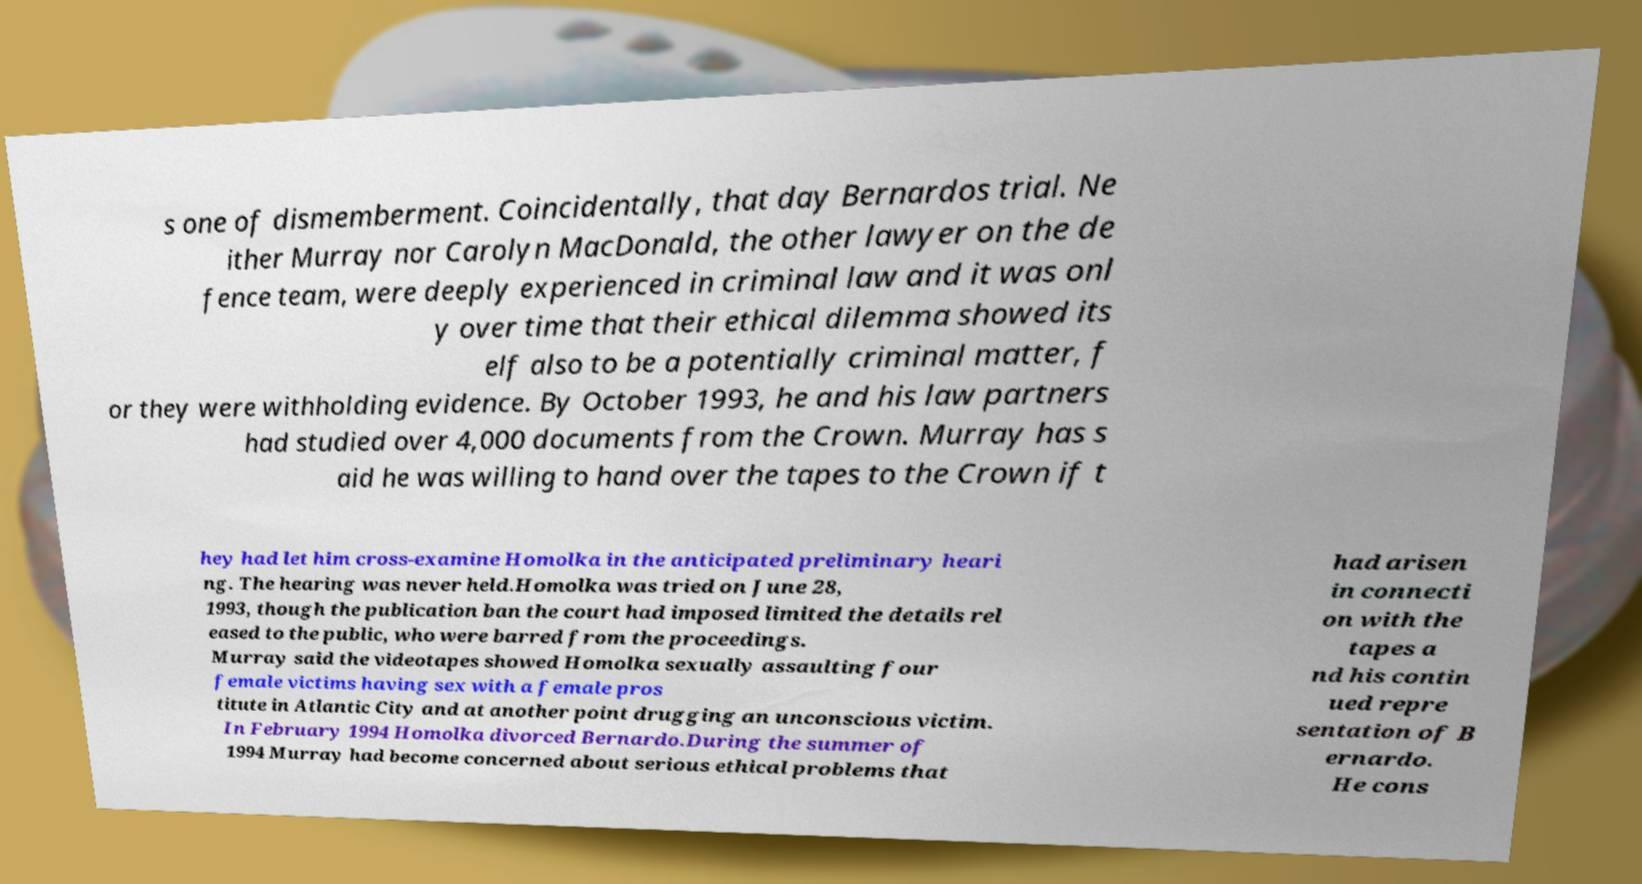Could you extract and type out the text from this image? s one of dismemberment. Coincidentally, that day Bernardos trial. Ne ither Murray nor Carolyn MacDonald, the other lawyer on the de fence team, were deeply experienced in criminal law and it was onl y over time that their ethical dilemma showed its elf also to be a potentially criminal matter, f or they were withholding evidence. By October 1993, he and his law partners had studied over 4,000 documents from the Crown. Murray has s aid he was willing to hand over the tapes to the Crown if t hey had let him cross-examine Homolka in the anticipated preliminary heari ng. The hearing was never held.Homolka was tried on June 28, 1993, though the publication ban the court had imposed limited the details rel eased to the public, who were barred from the proceedings. Murray said the videotapes showed Homolka sexually assaulting four female victims having sex with a female pros titute in Atlantic City and at another point drugging an unconscious victim. In February 1994 Homolka divorced Bernardo.During the summer of 1994 Murray had become concerned about serious ethical problems that had arisen in connecti on with the tapes a nd his contin ued repre sentation of B ernardo. He cons 